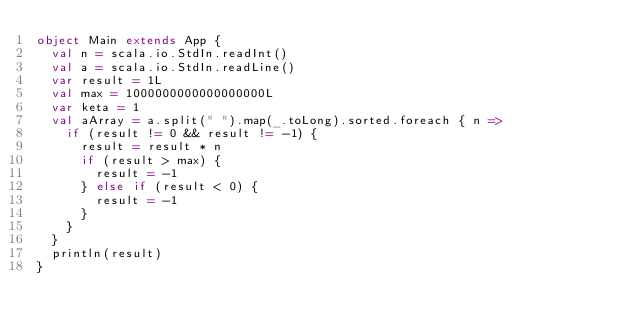<code> <loc_0><loc_0><loc_500><loc_500><_Scala_>object Main extends App {
  val n = scala.io.StdIn.readInt()
  val a = scala.io.StdIn.readLine()
  var result = 1L
  val max = 1000000000000000000L
  var keta = 1
  val aArray = a.split(" ").map(_.toLong).sorted.foreach { n =>
    if (result != 0 && result != -1) {
      result = result * n
      if (result > max) {
        result = -1
      } else if (result < 0) {
        result = -1
      }
    }
  }
  println(result)
}</code> 